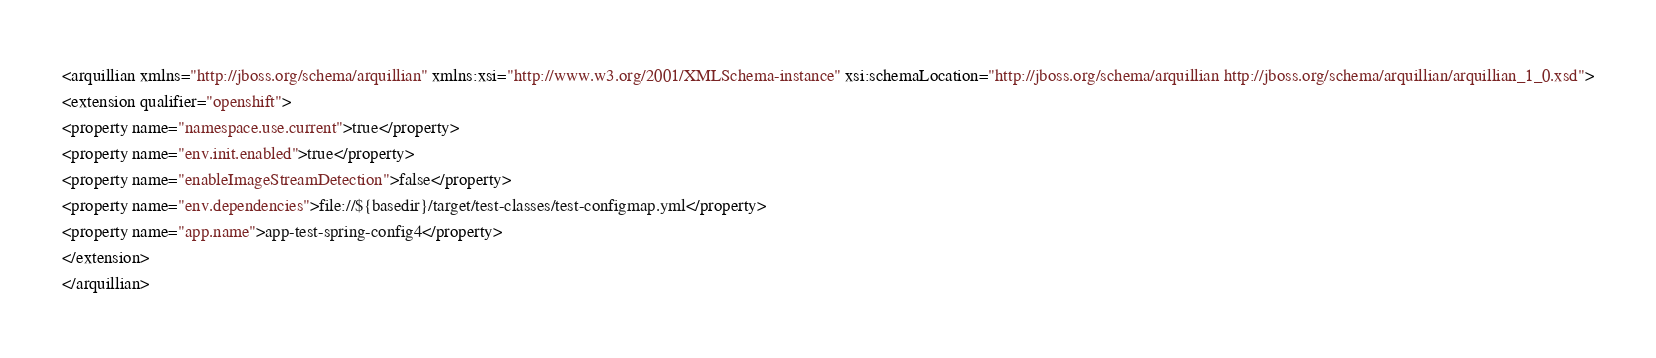Convert code to text. <code><loc_0><loc_0><loc_500><loc_500><_XML_><arquillian xmlns="http://jboss.org/schema/arquillian" xmlns:xsi="http://www.w3.org/2001/XMLSchema-instance" xsi:schemaLocation="http://jboss.org/schema/arquillian http://jboss.org/schema/arquillian/arquillian_1_0.xsd">
<extension qualifier="openshift">
<property name="namespace.use.current">true</property>
<property name="env.init.enabled">true</property>
<property name="enableImageStreamDetection">false</property>
<property name="env.dependencies">file://${basedir}/target/test-classes/test-configmap.yml</property>
<property name="app.name">app-test-spring-config4</property>
</extension>
</arquillian>
</code> 